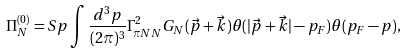<formula> <loc_0><loc_0><loc_500><loc_500>\Pi ^ { ( 0 ) } _ { N } = S p \int \frac { d ^ { 3 } p } { ( 2 \pi ) ^ { 3 } } \Gamma ^ { 2 } _ { \pi N N } G _ { N } ( \vec { p } + \vec { k } ) \theta ( | \vec { p } + \vec { k } | - p _ { F } ) \theta ( p _ { F } - p ) ,</formula> 